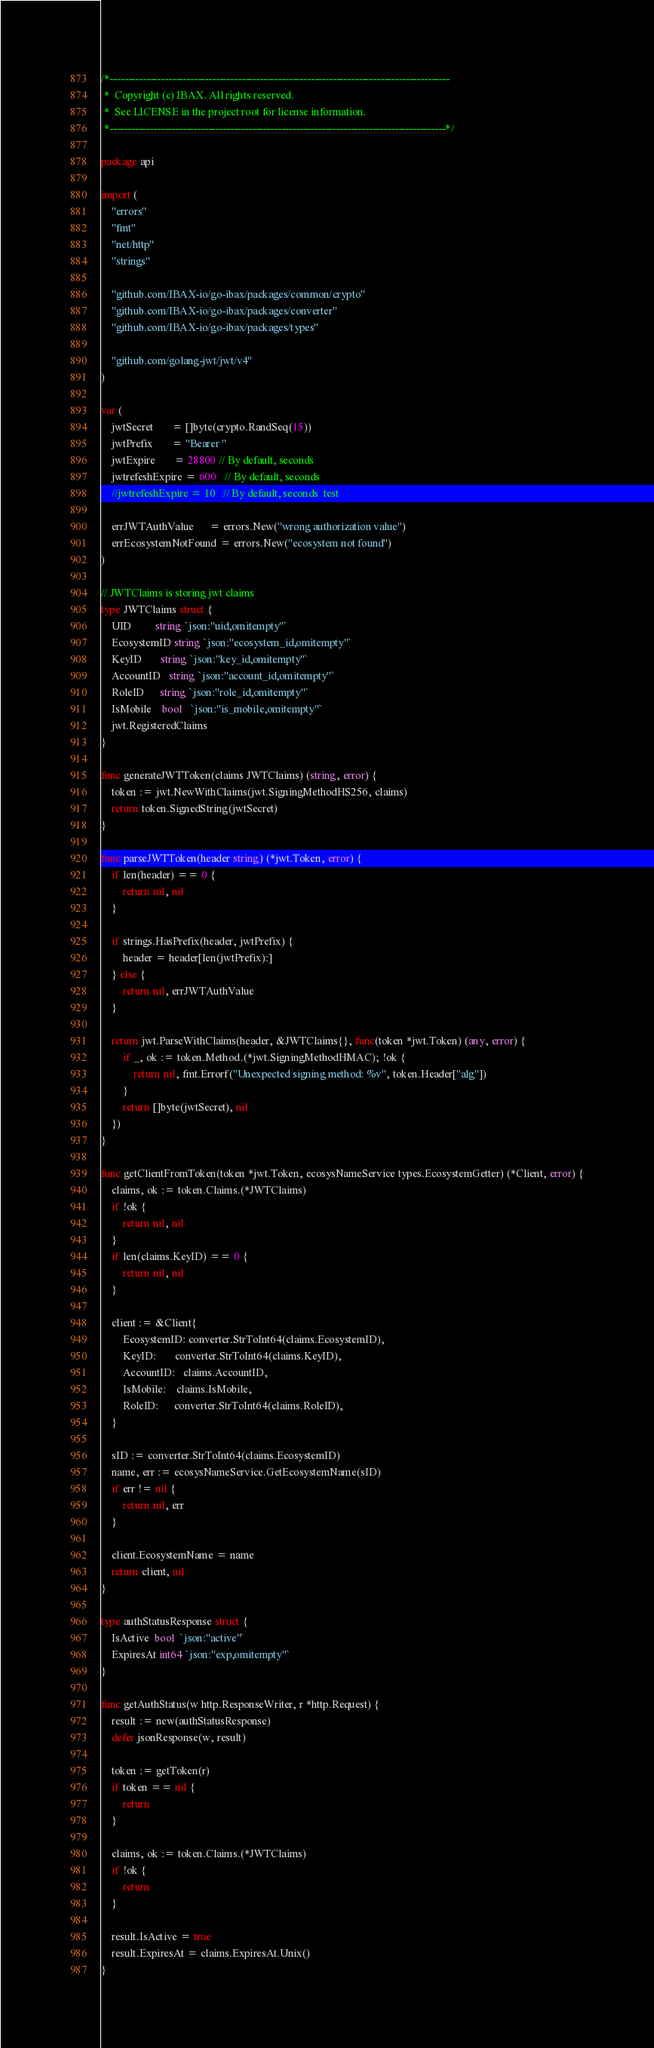<code> <loc_0><loc_0><loc_500><loc_500><_Go_>/*---------------------------------------------------------------------------------------------
 *  Copyright (c) IBAX. All rights reserved.
 *  See LICENSE in the project root for license information.
 *--------------------------------------------------------------------------------------------*/

package api

import (
	"errors"
	"fmt"
	"net/http"
	"strings"

	"github.com/IBAX-io/go-ibax/packages/common/crypto"
	"github.com/IBAX-io/go-ibax/packages/converter"
	"github.com/IBAX-io/go-ibax/packages/types"

	"github.com/golang-jwt/jwt/v4"
)

var (
	jwtSecret       = []byte(crypto.RandSeq(15))
	jwtPrefix       = "Bearer "
	jwtExpire       = 28800 // By default, seconds
	jwtrefeshExpire = 600   // By default, seconds
	//jwtrefeshExpire = 10   // By default, seconds  test

	errJWTAuthValue      = errors.New("wrong authorization value")
	errEcosystemNotFound = errors.New("ecosystem not found")
)

// JWTClaims is storing jwt claims
type JWTClaims struct {
	UID         string `json:"uid,omitempty"`
	EcosystemID string `json:"ecosystem_id,omitempty"`
	KeyID       string `json:"key_id,omitempty"`
	AccountID   string `json:"account_id,omitempty"`
	RoleID      string `json:"role_id,omitempty"`
	IsMobile    bool   `json:"is_mobile,omitempty"`
	jwt.RegisteredClaims
}

func generateJWTToken(claims JWTClaims) (string, error) {
	token := jwt.NewWithClaims(jwt.SigningMethodHS256, claims)
	return token.SignedString(jwtSecret)
}

func parseJWTToken(header string) (*jwt.Token, error) {
	if len(header) == 0 {
		return nil, nil
	}

	if strings.HasPrefix(header, jwtPrefix) {
		header = header[len(jwtPrefix):]
	} else {
		return nil, errJWTAuthValue
	}

	return jwt.ParseWithClaims(header, &JWTClaims{}, func(token *jwt.Token) (any, error) {
		if _, ok := token.Method.(*jwt.SigningMethodHMAC); !ok {
			return nil, fmt.Errorf("Unexpected signing method: %v", token.Header["alg"])
		}
		return []byte(jwtSecret), nil
	})
}

func getClientFromToken(token *jwt.Token, ecosysNameService types.EcosystemGetter) (*Client, error) {
	claims, ok := token.Claims.(*JWTClaims)
	if !ok {
		return nil, nil
	}
	if len(claims.KeyID) == 0 {
		return nil, nil
	}

	client := &Client{
		EcosystemID: converter.StrToInt64(claims.EcosystemID),
		KeyID:       converter.StrToInt64(claims.KeyID),
		AccountID:   claims.AccountID,
		IsMobile:    claims.IsMobile,
		RoleID:      converter.StrToInt64(claims.RoleID),
	}

	sID := converter.StrToInt64(claims.EcosystemID)
	name, err := ecosysNameService.GetEcosystemName(sID)
	if err != nil {
		return nil, err
	}

	client.EcosystemName = name
	return client, nil
}

type authStatusResponse struct {
	IsActive  bool  `json:"active"`
	ExpiresAt int64 `json:"exp,omitempty"`
}

func getAuthStatus(w http.ResponseWriter, r *http.Request) {
	result := new(authStatusResponse)
	defer jsonResponse(w, result)

	token := getToken(r)
	if token == nil {
		return
	}

	claims, ok := token.Claims.(*JWTClaims)
	if !ok {
		return
	}

	result.IsActive = true
	result.ExpiresAt = claims.ExpiresAt.Unix()
}
</code> 